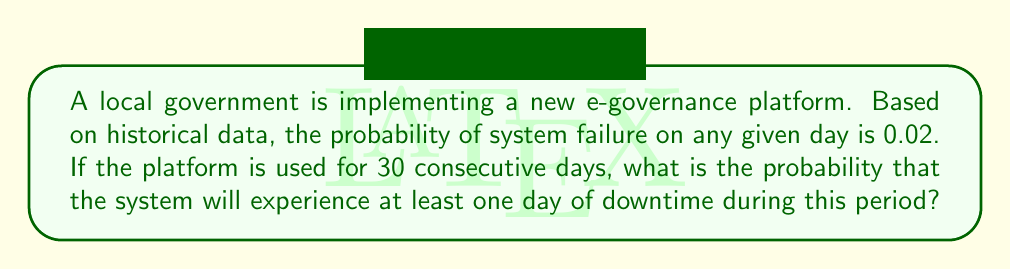Give your solution to this math problem. Let's approach this step-by-step:

1) First, let's define our events:
   Let A be the event "system experiences at least one day of downtime in 30 days"

2) It's easier to calculate the probability of the complement of A, which is "system has no downtime for 30 days"

3) The probability of the system working properly on any given day is:
   $1 - 0.02 = 0.98$

4) For the system to work properly for 30 consecutive days, it needs to work each day independently. We can use the multiplication rule of probability:

   $P(\text{no downtime for 30 days}) = 0.98^{30}$

5) We can calculate this:
   $0.98^{30} \approx 0.5475$

6) Now, the probability we're looking for is the complement of this probability:

   $P(A) = 1 - P(\text{no downtime for 30 days})$
   $= 1 - 0.98^{30}$
   $= 1 - 0.5475$
   $\approx 0.4525$

7) We can express this as a percentage:
   $0.4525 \times 100\% = 45.25\%$

This means there's about a 45.25% chance of experiencing at least one day of downtime in a 30-day period.
Answer: The probability that the e-governance platform will experience at least one day of downtime during a 30-day period is approximately 0.4525 or 45.25%. 